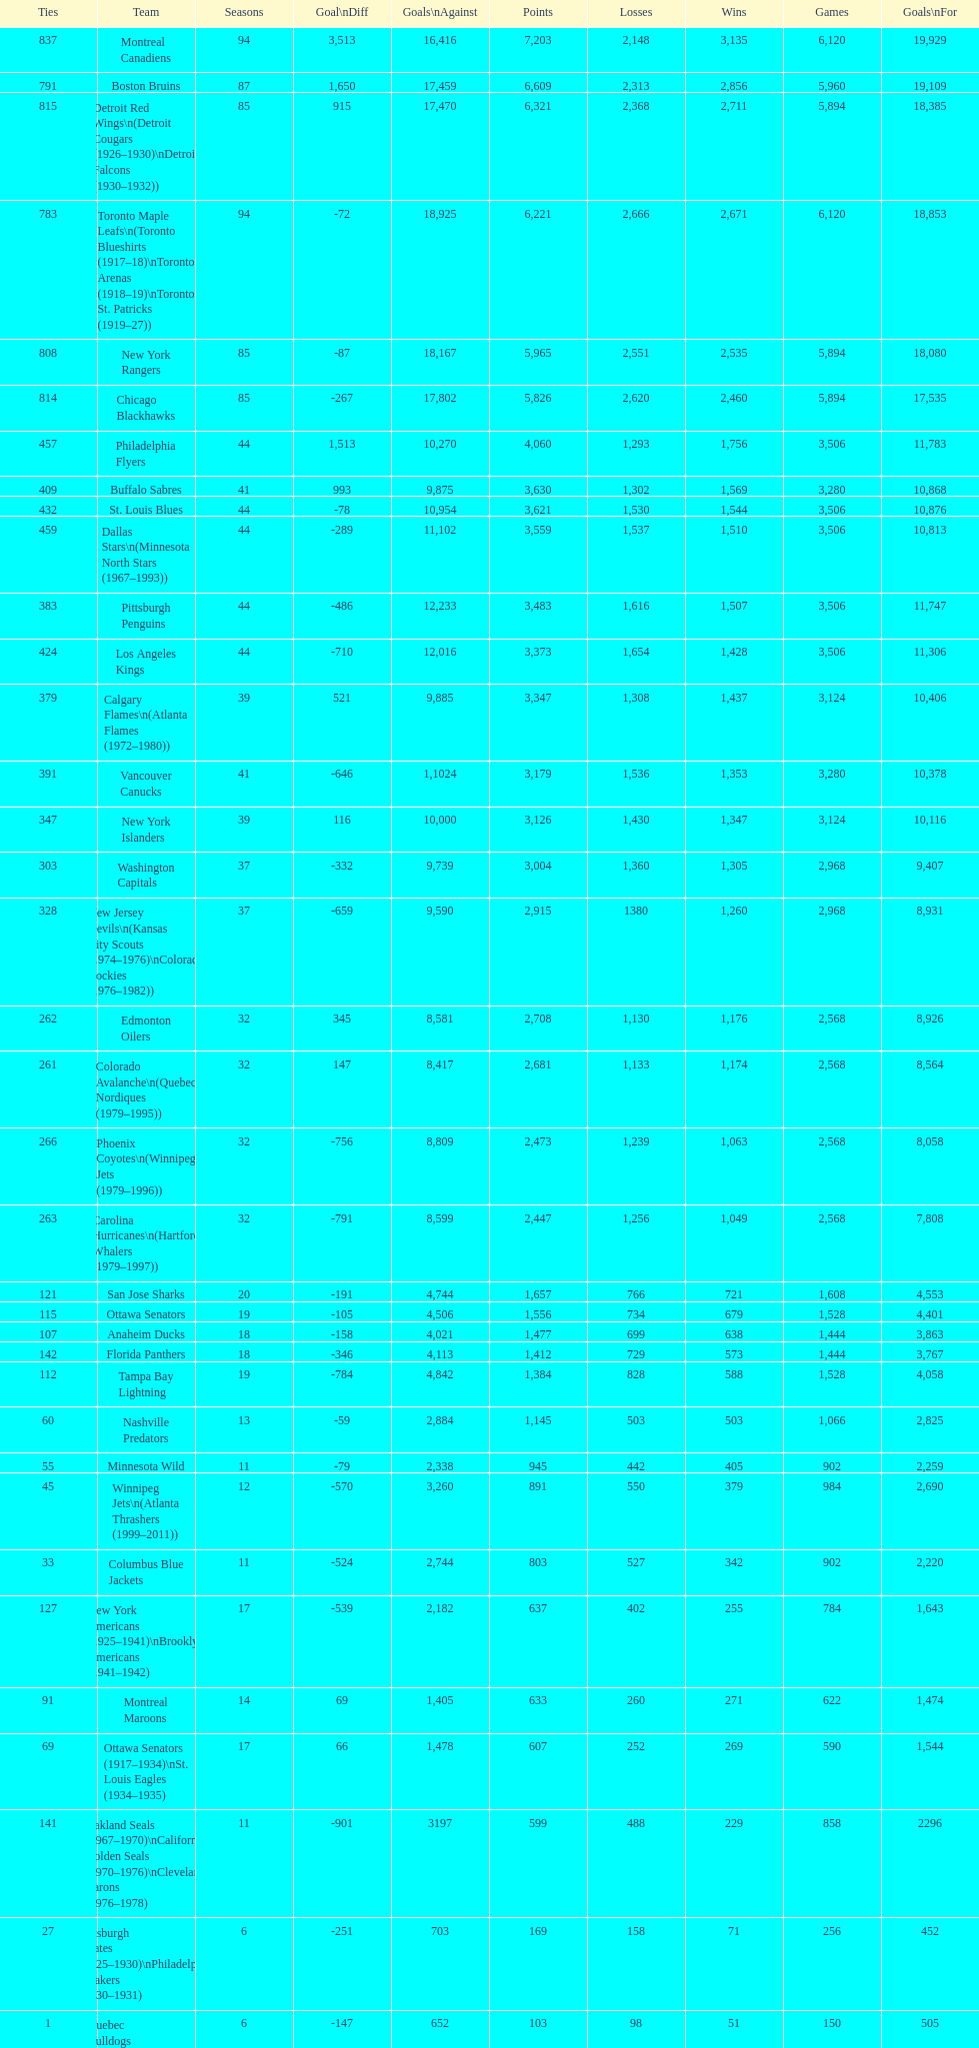What is the number of games that the vancouver canucks have won up to this point? 1,353. 